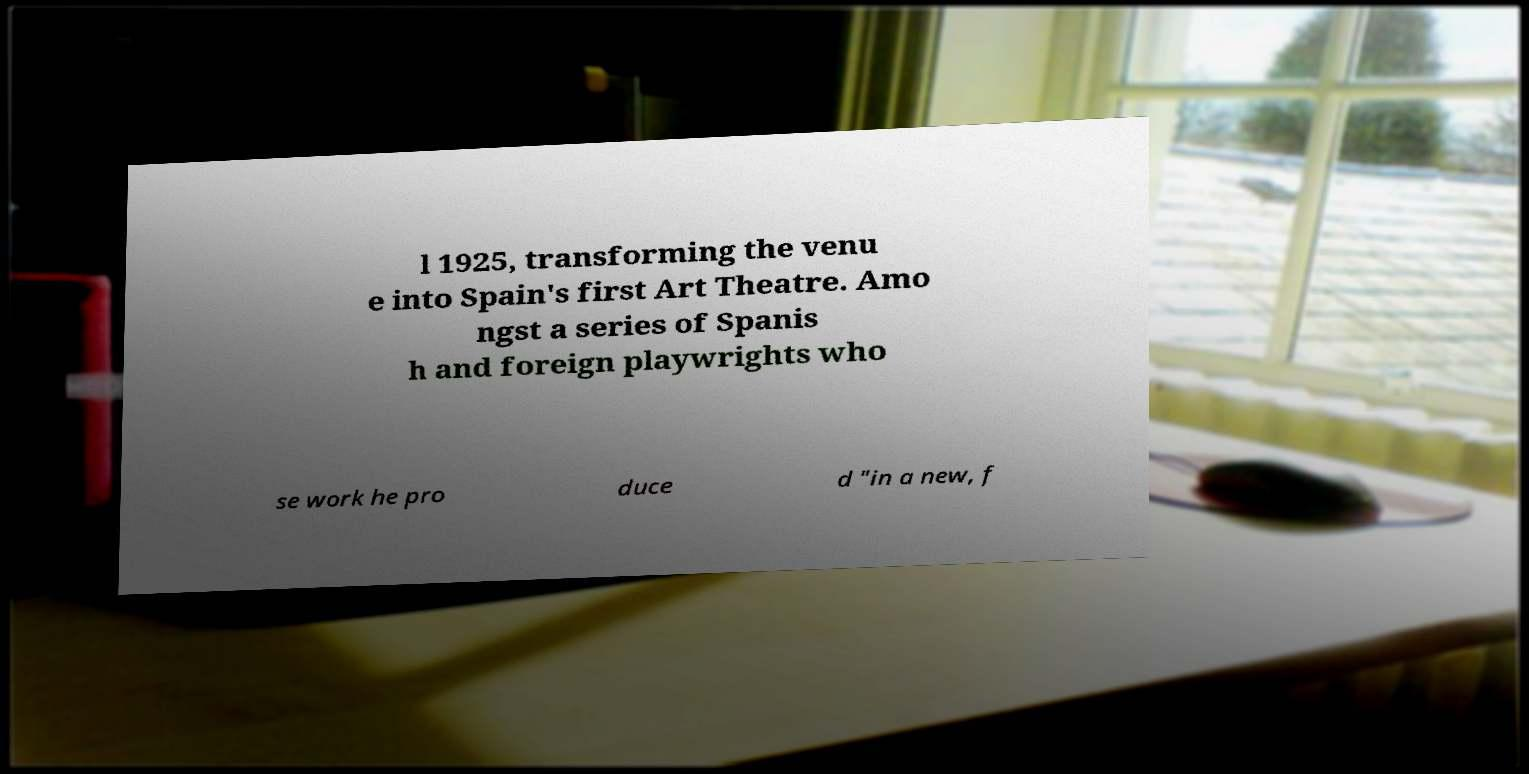Could you extract and type out the text from this image? l 1925, transforming the venu e into Spain's first Art Theatre. Amo ngst a series of Spanis h and foreign playwrights who se work he pro duce d "in a new, f 